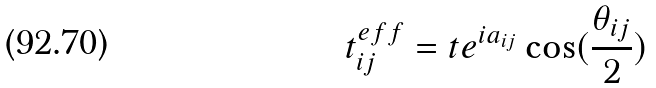<formula> <loc_0><loc_0><loc_500><loc_500>t ^ { e f f } _ { i j } = t e ^ { i a _ { i j } } \cos ( \frac { \theta _ { i j } } { 2 } )</formula> 